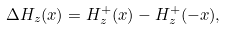Convert formula to latex. <formula><loc_0><loc_0><loc_500><loc_500>\Delta H _ { z } ( x ) = H _ { z } ^ { + } ( x ) - H _ { z } ^ { + } ( - x ) ,</formula> 